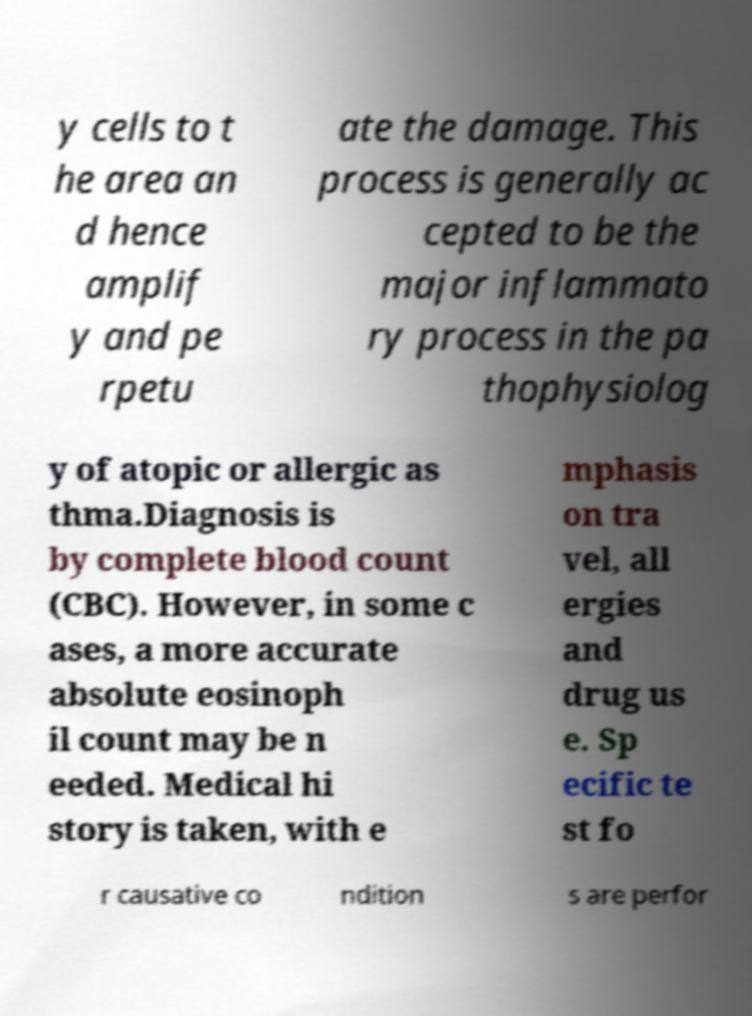For documentation purposes, I need the text within this image transcribed. Could you provide that? y cells to t he area an d hence amplif y and pe rpetu ate the damage. This process is generally ac cepted to be the major inflammato ry process in the pa thophysiolog y of atopic or allergic as thma.Diagnosis is by complete blood count (CBC). However, in some c ases, a more accurate absolute eosinoph il count may be n eeded. Medical hi story is taken, with e mphasis on tra vel, all ergies and drug us e. Sp ecific te st fo r causative co ndition s are perfor 